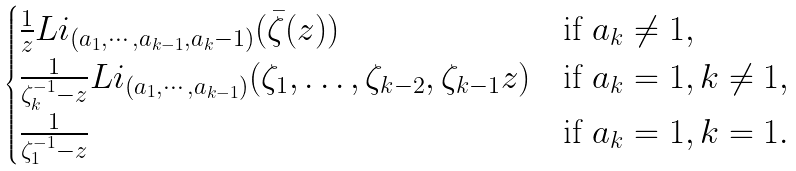Convert formula to latex. <formula><loc_0><loc_0><loc_500><loc_500>\begin{cases} \frac { 1 } { z } L i _ { ( a _ { 1 } , \cdots , a _ { k - 1 } , a _ { k } - 1 ) } ( \bar { \zeta } ( z ) ) & \text {if } a _ { k } \neq 1 , \\ \frac { 1 } { \zeta _ { k } ^ { - 1 } - z } L i _ { ( a _ { 1 } , \cdots , a _ { k - 1 } ) } ( \zeta _ { 1 } , \dots , \zeta _ { k - 2 } , \zeta _ { k - 1 } z ) & \text {if } a _ { k } = 1 , k \neq 1 , \\ \frac { 1 } { \zeta _ { 1 } ^ { - 1 } - z } & \text {if } a _ { k } = 1 , k = 1 . \\ \end{cases}</formula> 